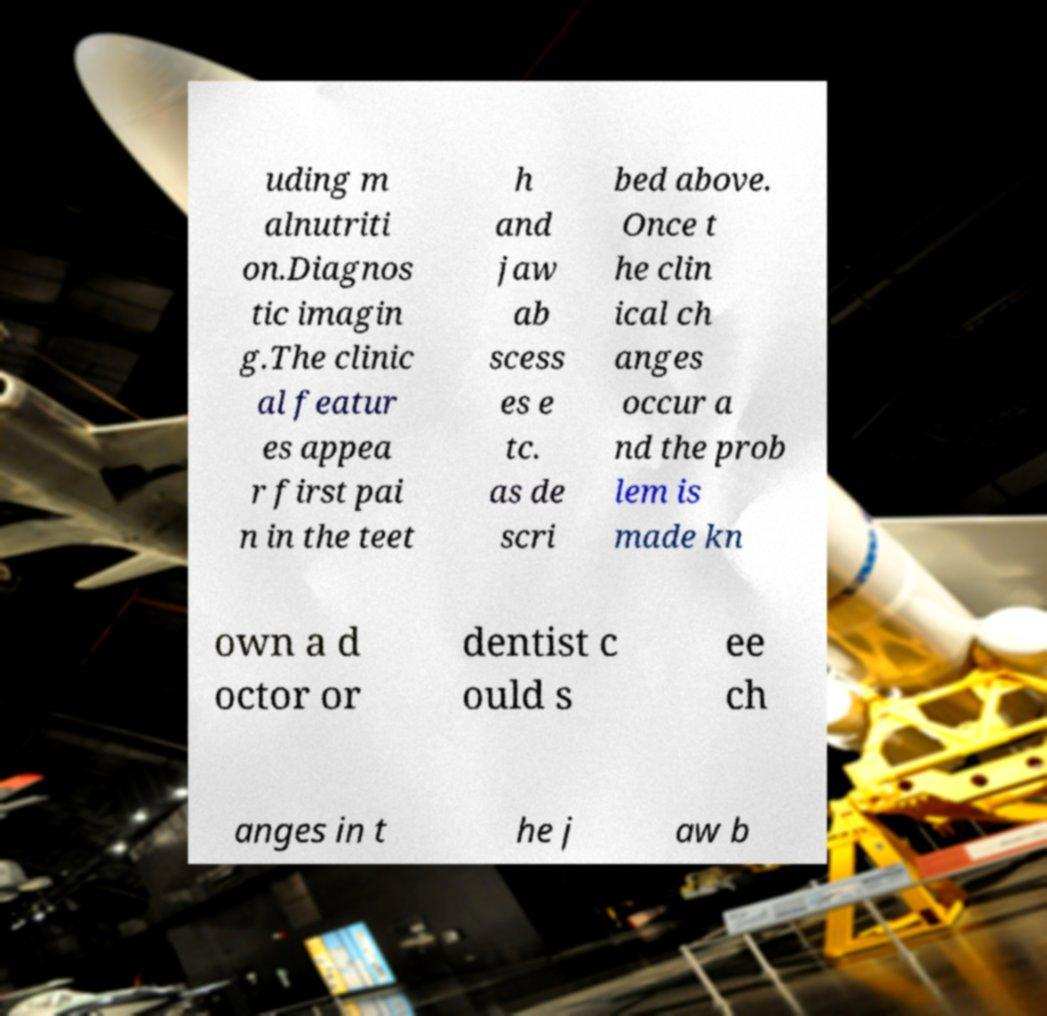Please read and relay the text visible in this image. What does it say? uding m alnutriti on.Diagnos tic imagin g.The clinic al featur es appea r first pai n in the teet h and jaw ab scess es e tc. as de scri bed above. Once t he clin ical ch anges occur a nd the prob lem is made kn own a d octor or dentist c ould s ee ch anges in t he j aw b 